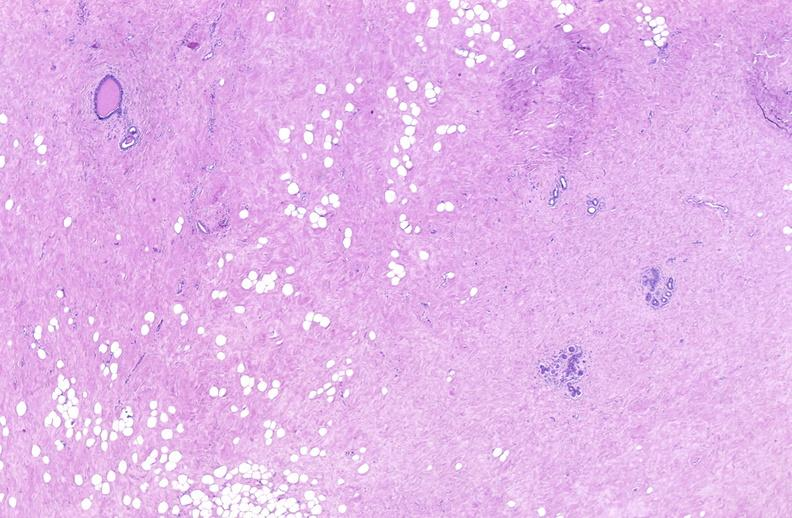what does this image show?
Answer the question using a single word or phrase. Breast 